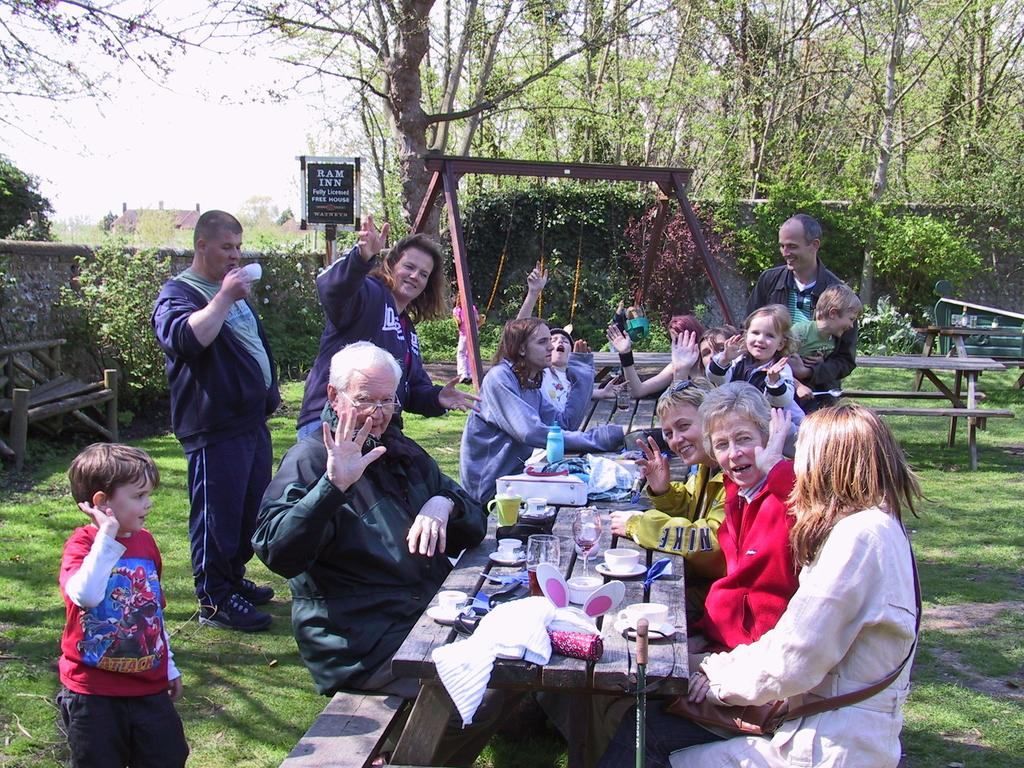What is happening in the image involving a group of people? There is a group of people in the image, and they are sitting on a wooden chair. How are the people interacting with each other in the image? The people are enjoying themselves in the image. What can be seen in the background of the image? There are trees and the sky visible in the background of the image. What type of transport is being used by the people in the image? There is no transport visible in the image; the people are sitting on a wooden chair. 